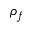Convert formula to latex. <formula><loc_0><loc_0><loc_500><loc_500>\rho _ { f }</formula> 